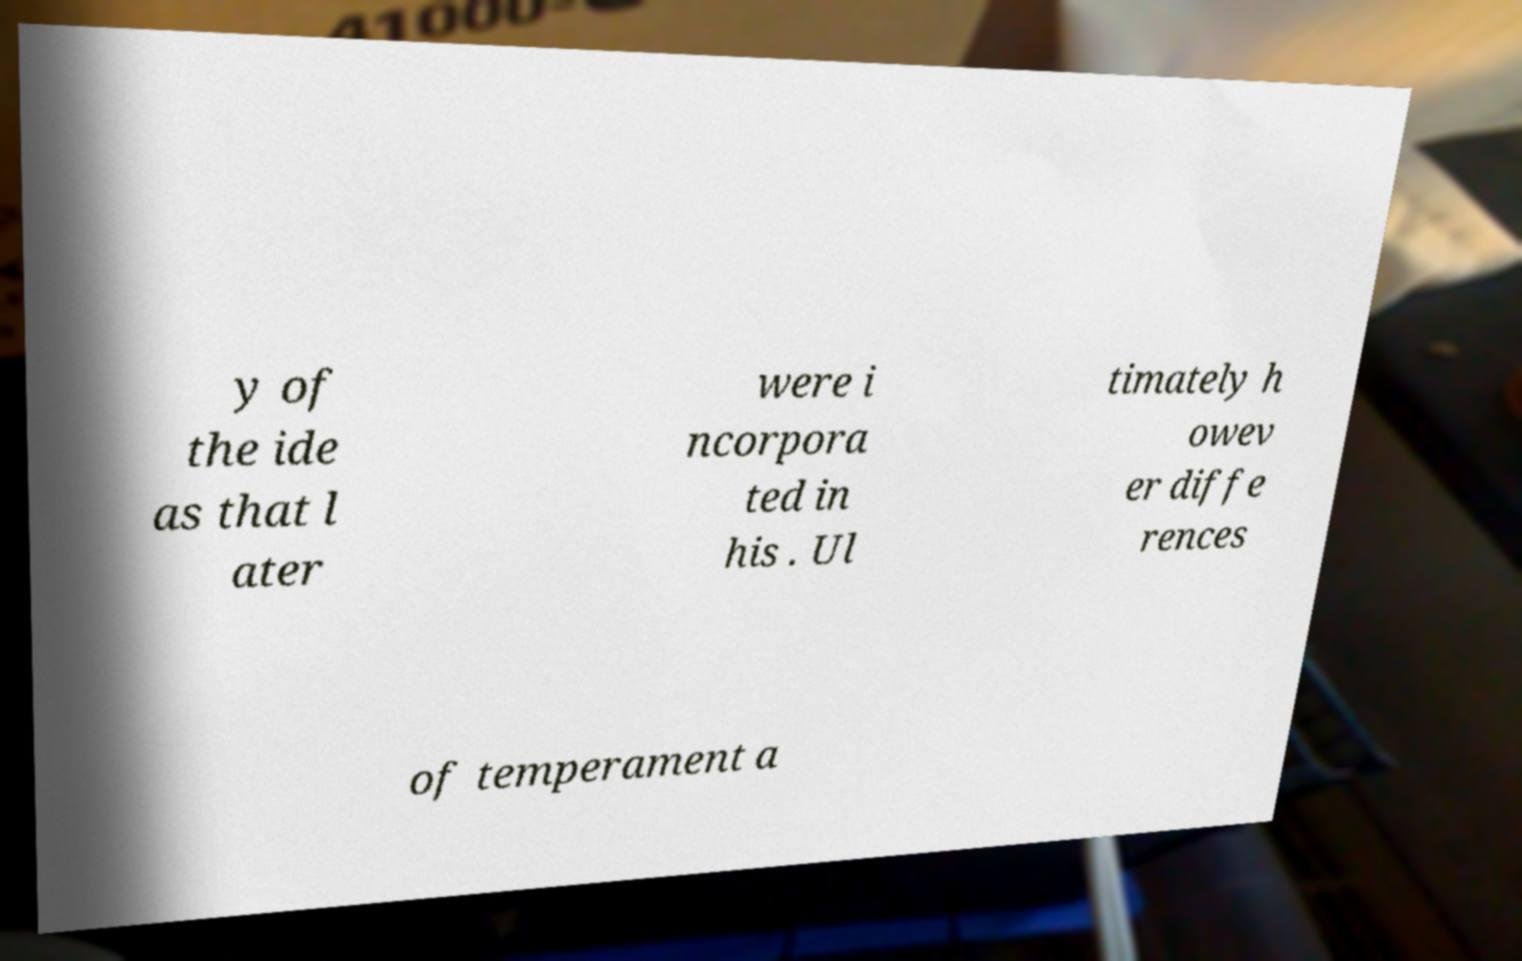I need the written content from this picture converted into text. Can you do that? y of the ide as that l ater were i ncorpora ted in his . Ul timately h owev er diffe rences of temperament a 